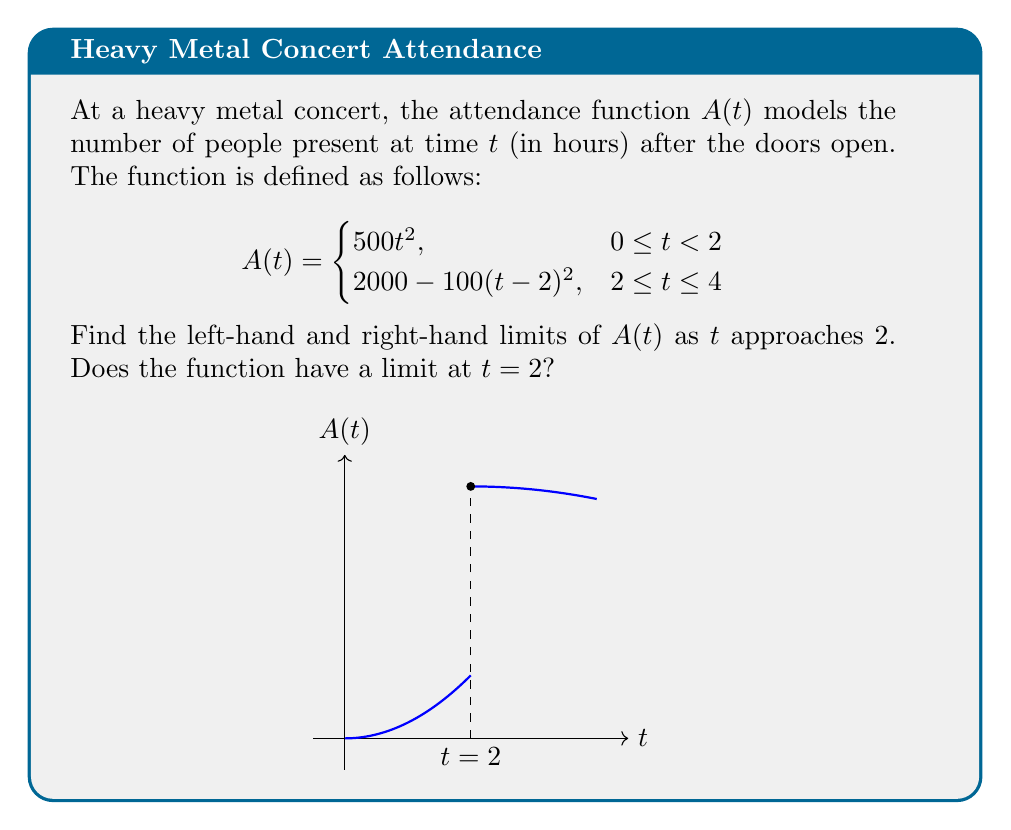Provide a solution to this math problem. Let's approach this step-by-step:

1) For the left-hand limit, we need to evaluate $\lim_{t \to 2^-} A(t)$:
   $$\lim_{t \to 2^-} A(t) = \lim_{t \to 2^-} 500t^2$$
   $$= 500 \cdot 2^2 = 2000$$

2) For the right-hand limit, we evaluate $\lim_{t \to 2^+} A(t)$:
   $$\lim_{t \to 2^+} A(t) = \lim_{t \to 2^+} [2000 - 100(t-2)^2]$$
   $$= 2000 - 100 \cdot 0^2 = 2000$$

3) We can see that both the left-hand and right-hand limits exist and are equal:
   $$\lim_{t \to 2^-} A(t) = \lim_{t \to 2^+} A(t) = 2000$$

4) Since both one-sided limits exist and are equal, the function has a limit at $t = 2$:
   $$\lim_{t \to 2} A(t) = 2000$$

This result matches our intuition from the graph, where we can see the function is continuous at $t = 2$.
Answer: $\lim_{t \to 2^-} A(t) = 2000$, $\lim_{t \to 2^+} A(t) = 2000$, $\lim_{t \to 2} A(t) = 2000$ 